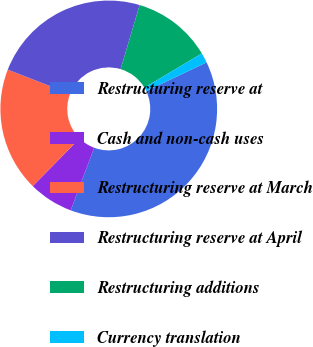<chart> <loc_0><loc_0><loc_500><loc_500><pie_chart><fcel>Restructuring reserve at<fcel>Cash and non-cash uses<fcel>Restructuring reserve at March<fcel>Restructuring reserve at April<fcel>Restructuring additions<fcel>Currency translation<nl><fcel>37.78%<fcel>6.67%<fcel>18.52%<fcel>23.7%<fcel>11.85%<fcel>1.48%<nl></chart> 